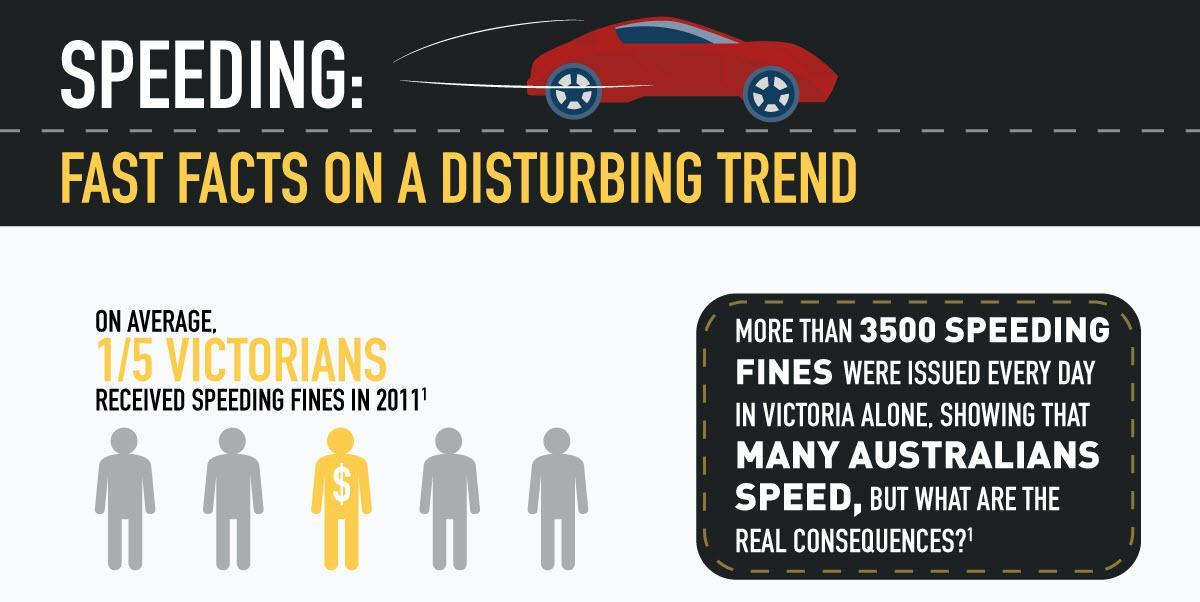How many persons with Dollar symbol are depicted in the info graphic?
Answer the question with a short phrase. 1 How many fines are issued in Victoria each day? more than 3500 How many out of five where fined for speeding in Victoria ? 4 How many person images are shown in grey color? 4 What is the color of the car shown in the info graphic- yellow, orange, red or green? red 